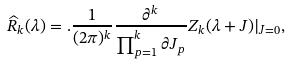Convert formula to latex. <formula><loc_0><loc_0><loc_500><loc_500>\widehat { R } _ { k } ( \lambda ) = . \frac { 1 } { ( 2 \pi ) ^ { k } } \frac { \partial ^ { k } } { \prod _ { p = 1 } ^ { k } \partial J _ { p } } Z _ { k } ( \lambda + J ) | _ { J = 0 } ,</formula> 